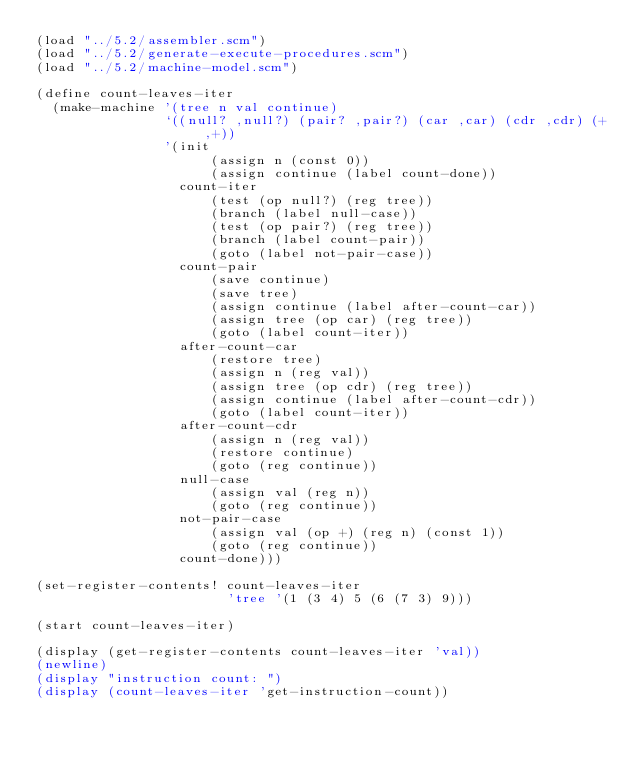Convert code to text. <code><loc_0><loc_0><loc_500><loc_500><_Scheme_>(load "../5.2/assembler.scm")
(load "../5.2/generate-execute-procedures.scm")
(load "../5.2/machine-model.scm")

(define count-leaves-iter
  (make-machine '(tree n val continue)
                `((null? ,null?) (pair? ,pair?) (car ,car) (cdr ,cdr) (+ ,+))
                '(init
                      (assign n (const 0))
                      (assign continue (label count-done))
                  count-iter
                      (test (op null?) (reg tree))
                      (branch (label null-case))
                      (test (op pair?) (reg tree))
                      (branch (label count-pair))
                      (goto (label not-pair-case))
                  count-pair
                      (save continue)
                      (save tree)
                      (assign continue (label after-count-car))
                      (assign tree (op car) (reg tree))
                      (goto (label count-iter))
                  after-count-car
                      (restore tree)
                      (assign n (reg val))
                      (assign tree (op cdr) (reg tree))
                      (assign continue (label after-count-cdr))
                      (goto (label count-iter))
                  after-count-cdr
                      (assign n (reg val))
                      (restore continue)
                      (goto (reg continue))
                  null-case
                      (assign val (reg n))
                      (goto (reg continue))
                  not-pair-case
                      (assign val (op +) (reg n) (const 1))
                      (goto (reg continue))
                  count-done)))

(set-register-contents! count-leaves-iter
                        'tree '(1 (3 4) 5 (6 (7 3) 9)))

(start count-leaves-iter)

(display (get-register-contents count-leaves-iter 'val))
(newline)
(display "instruction count: ")
(display (count-leaves-iter 'get-instruction-count))</code> 